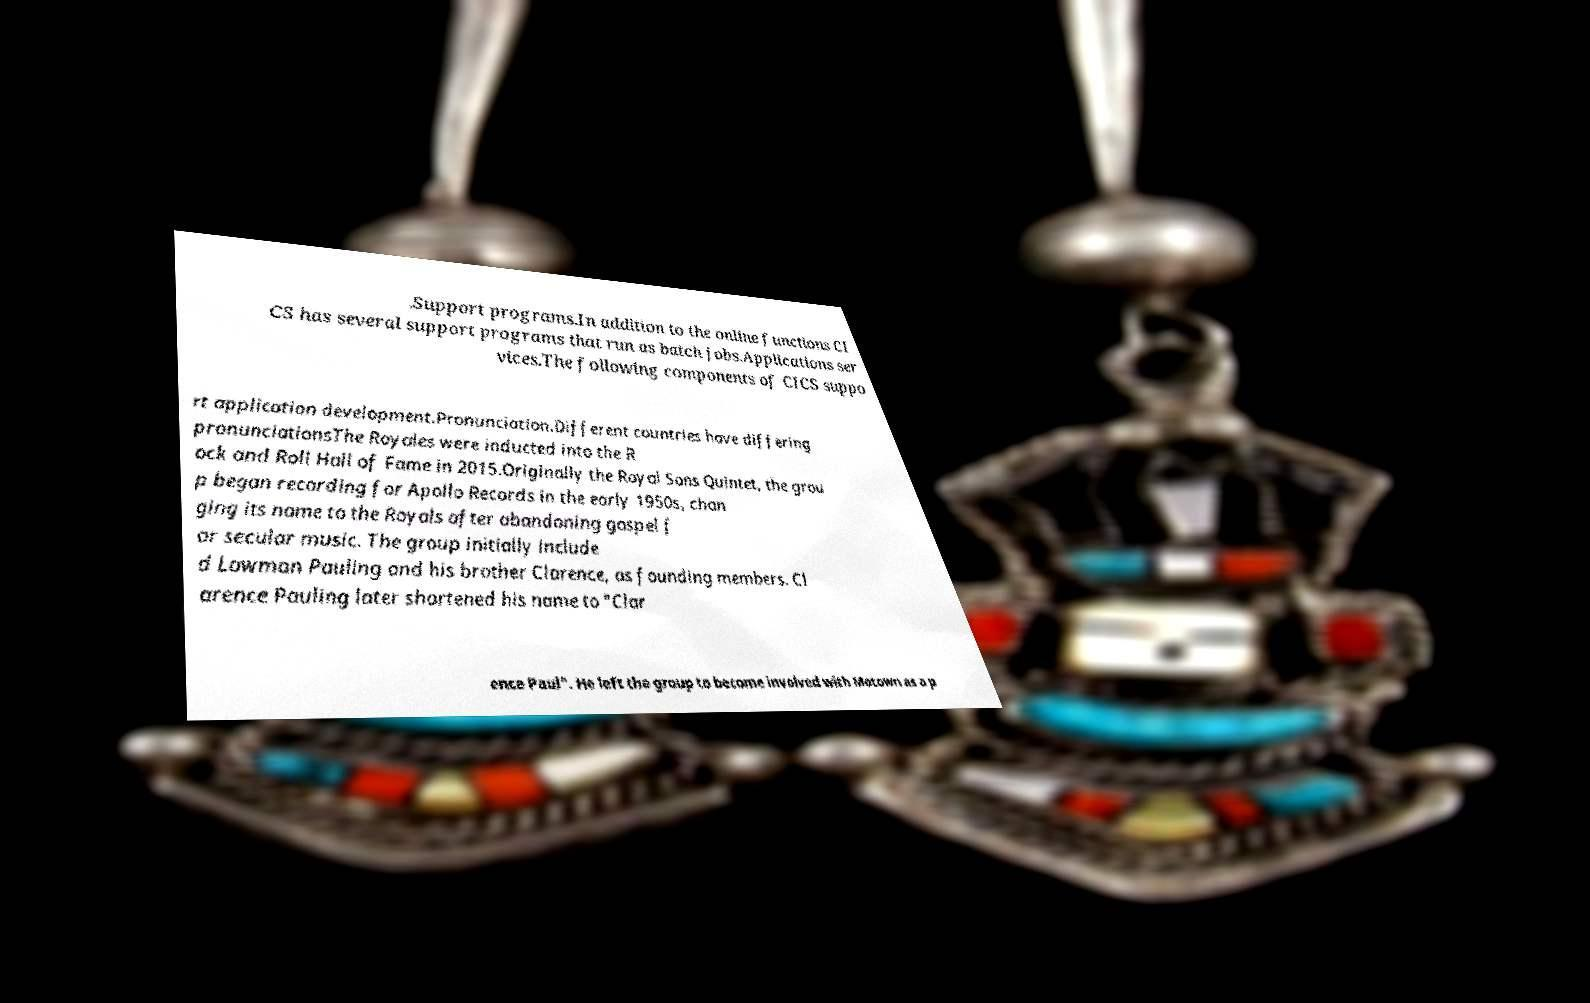Can you read and provide the text displayed in the image?This photo seems to have some interesting text. Can you extract and type it out for me? .Support programs.In addition to the online functions CI CS has several support programs that run as batch jobs.Applications ser vices.The following components of CICS suppo rt application development.Pronunciation.Different countries have differing pronunciationsThe Royales were inducted into the R ock and Roll Hall of Fame in 2015.Originally the Royal Sons Quintet, the grou p began recording for Apollo Records in the early 1950s, chan ging its name to the Royals after abandoning gospel f or secular music. The group initially include d Lowman Pauling and his brother Clarence, as founding members. Cl arence Pauling later shortened his name to "Clar ence Paul". He left the group to become involved with Motown as a p 